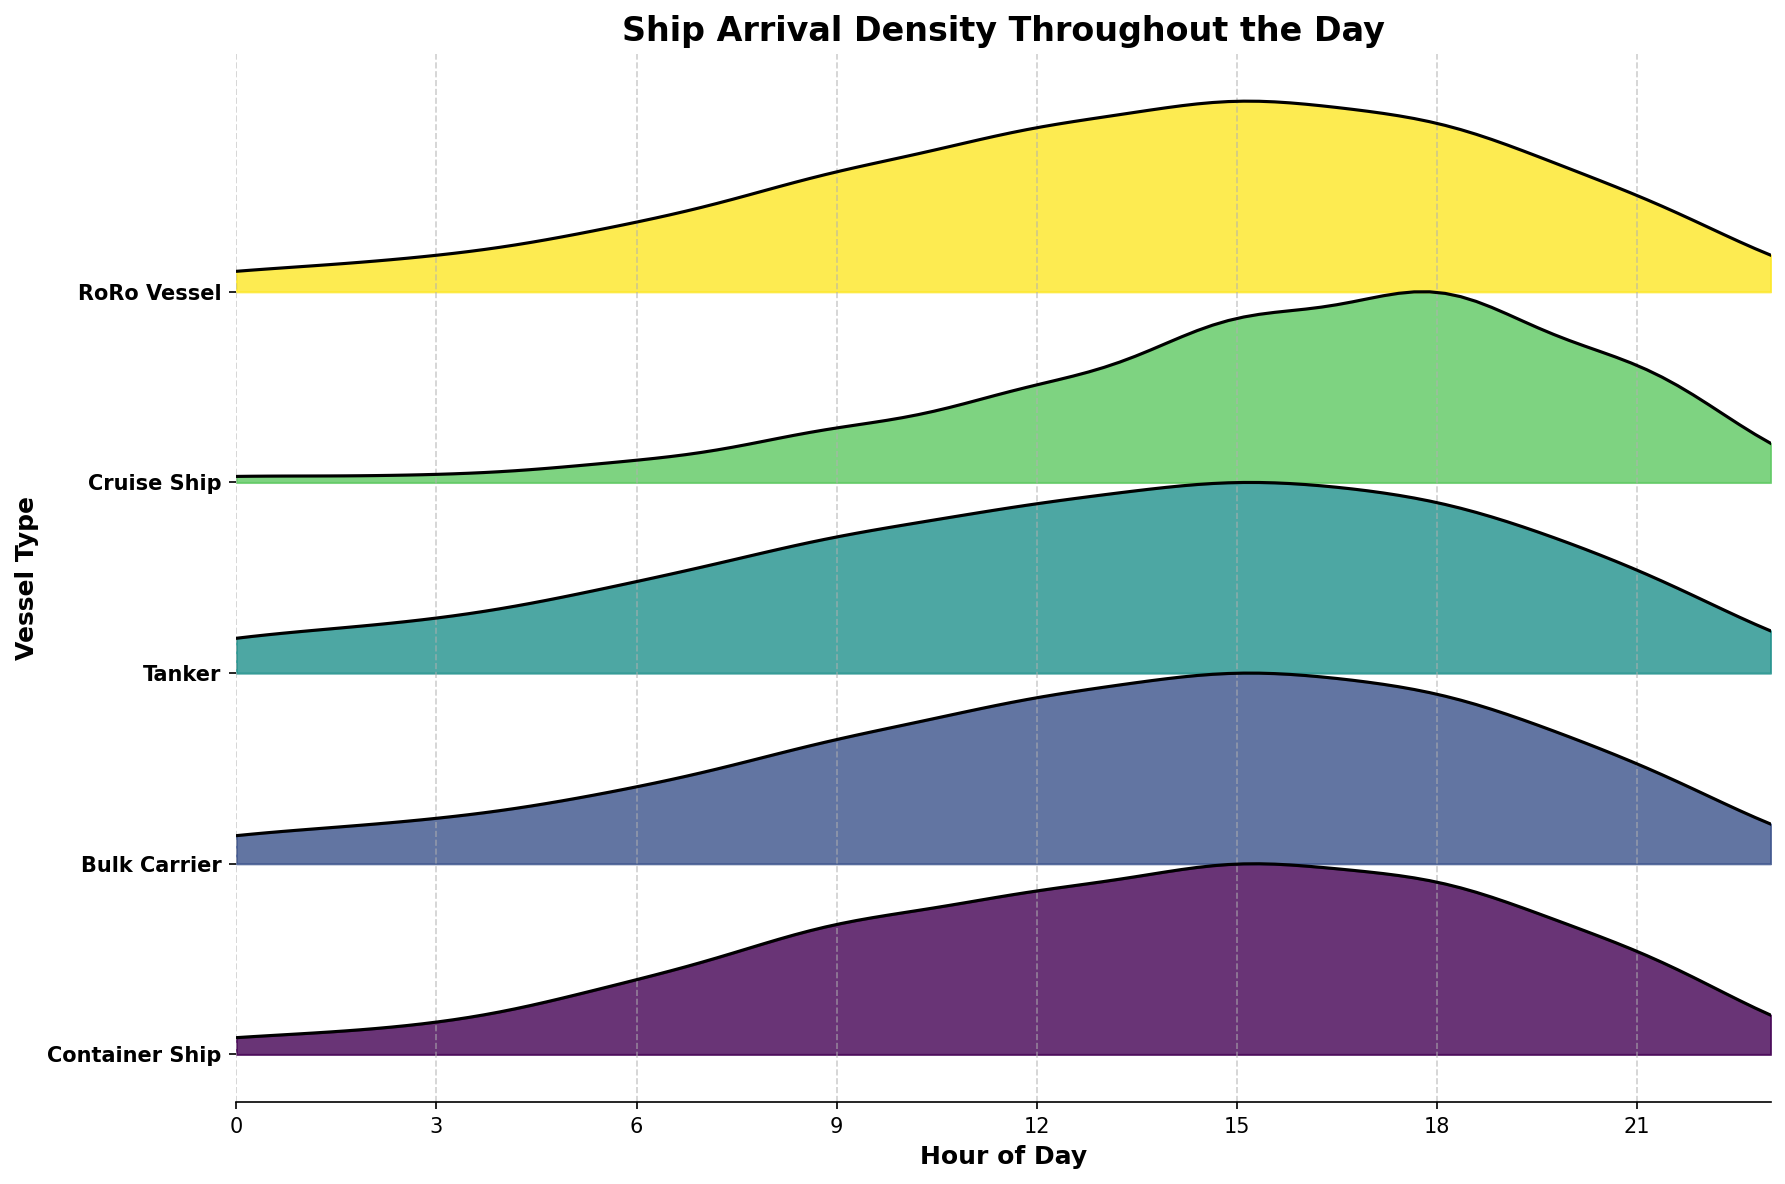What are the vessel types shown in the plot? The y-axis labels represent different vessel types. By reading the y-axis, you can see the types of vessels included in the plot.
Answer: Container Ship, Bulk Carrier, Tanker, Cruise Ship, RoRo Vessel At what hour of the day is the arrival density highest for RoRo vessels? The curve for RoRo vessels peaks around a certain time on the x-axis. By finding the maximum point on the RoRo vessel's curve, you see it occurs in the late afternoon.
Answer: 18:00 Which vessel type shows the highest density peak overall? By comparing the peaks of each vessel's density curve, the one with the highest peak value stands out. The curve for Cruise Ships has the highest value.
Answer: Cruise Ship Is the arrival density for Tankers higher at 18:00 or 06:00? To compare these times, locate the density value for the Tanker vessel at both 18:00 and 06:00 on the plot. The peak at 18:00 is visibly higher.
Answer: 18:00 What is the general trend in arrival density for Container Ships throughout the day? By visually following the Container Ship's density curve from 0 to 23 hours, you can describe the overall trend. The density starts low, rises to a peak in the afternoon, then decreases.
Answer: Low to high to low Compare the arrival density at 12:00 for Bulk Carriers and Cruise Ships. Which is higher? By finding the density value for both vessel types at 12:00, you see the height of their respective curves. The Cruise Ships have a higher density at 12:00 compared to Bulk Carriers.
Answer: Cruise Ships For which vessel type is the peak arrival density at midday the most pronounced? By looking at the peak of each vessel type's arrival density around midday, identify the most pronounced peak. The Cruise Ship's peak at 12:00 stands out as most pronounced.
Answer: Cruise Ship Which vessel type has the most balanced (least variable) arrival density throughout the day? To determine the most balanced arrival density, check which vessel type shows the least fluctuation in its density curve across the day. The Bulk Carrier's density is relatively stable compared to others.
Answer: Bulk Carrier Which vessel type has the least arrival density during the evening hours (18:00 to 21:00)? Examine the density curves for all vessel types during the evening hours. The one with the lowest values in this timeframe belongs to RoRo vessels.
Answer: RoRo Vessel How does the arrival density trend for Tankers compare between the early morning (0:00 to 6:00) and the late evening (18:00 to 23:00)? Compare the Tanker's density values in the early morning to the late evening. Density increases slowly in the early hours and decreases slowly in the late evening, indicating a smoother distribution.
Answer: Increases and decreases 